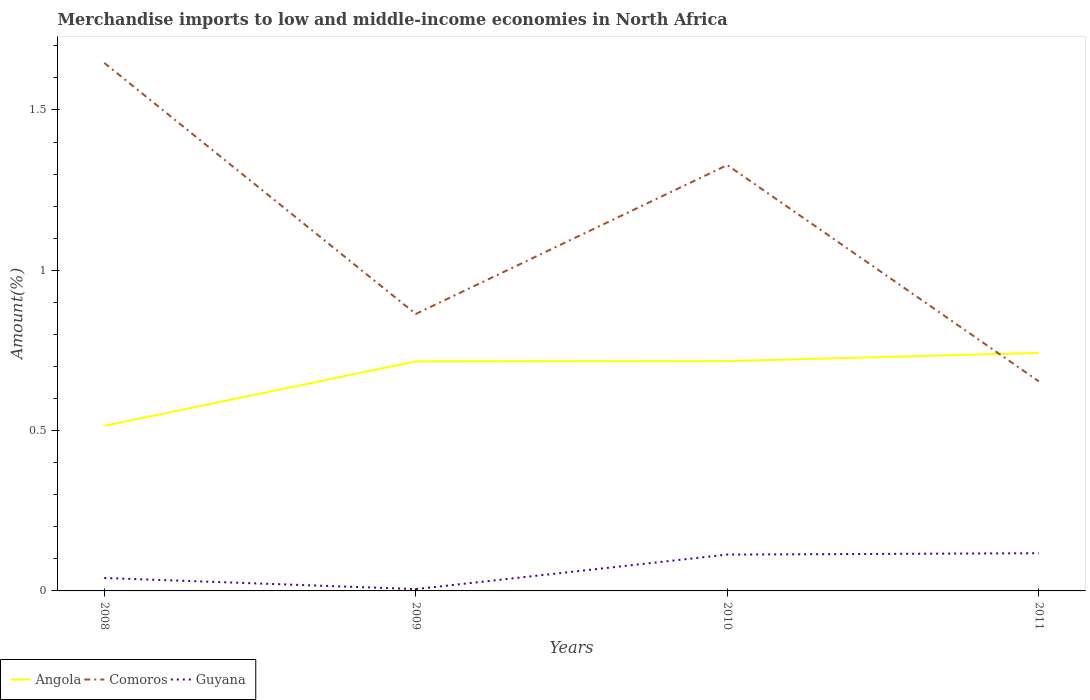Does the line corresponding to Comoros intersect with the line corresponding to Angola?
Provide a succinct answer. Yes. Across all years, what is the maximum percentage of amount earned from merchandise imports in Comoros?
Your response must be concise. 0.65. In which year was the percentage of amount earned from merchandise imports in Angola maximum?
Provide a short and direct response. 2008. What is the total percentage of amount earned from merchandise imports in Comoros in the graph?
Give a very brief answer. 0.99. What is the difference between the highest and the second highest percentage of amount earned from merchandise imports in Comoros?
Your response must be concise. 0.99. What is the difference between the highest and the lowest percentage of amount earned from merchandise imports in Guyana?
Give a very brief answer. 2. What is the difference between two consecutive major ticks on the Y-axis?
Offer a very short reply. 0.5. Does the graph contain any zero values?
Offer a very short reply. No. Does the graph contain grids?
Offer a very short reply. No. Where does the legend appear in the graph?
Ensure brevity in your answer.  Bottom left. How many legend labels are there?
Your response must be concise. 3. How are the legend labels stacked?
Give a very brief answer. Horizontal. What is the title of the graph?
Make the answer very short. Merchandise imports to low and middle-income economies in North Africa. Does "Tunisia" appear as one of the legend labels in the graph?
Provide a short and direct response. No. What is the label or title of the Y-axis?
Ensure brevity in your answer.  Amount(%). What is the Amount(%) in Angola in 2008?
Provide a succinct answer. 0.51. What is the Amount(%) of Comoros in 2008?
Your answer should be very brief. 1.65. What is the Amount(%) in Guyana in 2008?
Your response must be concise. 0.04. What is the Amount(%) of Angola in 2009?
Provide a short and direct response. 0.72. What is the Amount(%) of Comoros in 2009?
Give a very brief answer. 0.86. What is the Amount(%) in Guyana in 2009?
Your answer should be compact. 0.01. What is the Amount(%) in Angola in 2010?
Your answer should be very brief. 0.72. What is the Amount(%) in Comoros in 2010?
Provide a short and direct response. 1.33. What is the Amount(%) of Guyana in 2010?
Provide a succinct answer. 0.11. What is the Amount(%) in Angola in 2011?
Provide a short and direct response. 0.74. What is the Amount(%) of Comoros in 2011?
Make the answer very short. 0.65. What is the Amount(%) in Guyana in 2011?
Provide a short and direct response. 0.12. Across all years, what is the maximum Amount(%) in Angola?
Ensure brevity in your answer.  0.74. Across all years, what is the maximum Amount(%) of Comoros?
Your response must be concise. 1.65. Across all years, what is the maximum Amount(%) in Guyana?
Provide a succinct answer. 0.12. Across all years, what is the minimum Amount(%) of Angola?
Give a very brief answer. 0.51. Across all years, what is the minimum Amount(%) of Comoros?
Give a very brief answer. 0.65. Across all years, what is the minimum Amount(%) in Guyana?
Provide a short and direct response. 0.01. What is the total Amount(%) of Angola in the graph?
Offer a terse response. 2.69. What is the total Amount(%) in Comoros in the graph?
Your answer should be very brief. 4.49. What is the total Amount(%) of Guyana in the graph?
Keep it short and to the point. 0.28. What is the difference between the Amount(%) in Angola in 2008 and that in 2009?
Your response must be concise. -0.2. What is the difference between the Amount(%) in Comoros in 2008 and that in 2009?
Provide a succinct answer. 0.78. What is the difference between the Amount(%) in Guyana in 2008 and that in 2009?
Provide a succinct answer. 0.03. What is the difference between the Amount(%) in Angola in 2008 and that in 2010?
Ensure brevity in your answer.  -0.2. What is the difference between the Amount(%) of Comoros in 2008 and that in 2010?
Offer a very short reply. 0.32. What is the difference between the Amount(%) in Guyana in 2008 and that in 2010?
Keep it short and to the point. -0.07. What is the difference between the Amount(%) in Angola in 2008 and that in 2011?
Offer a terse response. -0.23. What is the difference between the Amount(%) in Comoros in 2008 and that in 2011?
Give a very brief answer. 0.99. What is the difference between the Amount(%) in Guyana in 2008 and that in 2011?
Your answer should be compact. -0.08. What is the difference between the Amount(%) in Angola in 2009 and that in 2010?
Your answer should be very brief. -0. What is the difference between the Amount(%) in Comoros in 2009 and that in 2010?
Your response must be concise. -0.46. What is the difference between the Amount(%) of Guyana in 2009 and that in 2010?
Keep it short and to the point. -0.11. What is the difference between the Amount(%) of Angola in 2009 and that in 2011?
Your response must be concise. -0.03. What is the difference between the Amount(%) in Comoros in 2009 and that in 2011?
Offer a terse response. 0.21. What is the difference between the Amount(%) of Guyana in 2009 and that in 2011?
Ensure brevity in your answer.  -0.11. What is the difference between the Amount(%) in Angola in 2010 and that in 2011?
Provide a short and direct response. -0.03. What is the difference between the Amount(%) of Comoros in 2010 and that in 2011?
Ensure brevity in your answer.  0.67. What is the difference between the Amount(%) in Guyana in 2010 and that in 2011?
Ensure brevity in your answer.  -0. What is the difference between the Amount(%) of Angola in 2008 and the Amount(%) of Comoros in 2009?
Your answer should be very brief. -0.35. What is the difference between the Amount(%) of Angola in 2008 and the Amount(%) of Guyana in 2009?
Your response must be concise. 0.51. What is the difference between the Amount(%) in Comoros in 2008 and the Amount(%) in Guyana in 2009?
Keep it short and to the point. 1.64. What is the difference between the Amount(%) in Angola in 2008 and the Amount(%) in Comoros in 2010?
Give a very brief answer. -0.81. What is the difference between the Amount(%) in Angola in 2008 and the Amount(%) in Guyana in 2010?
Provide a short and direct response. 0.4. What is the difference between the Amount(%) of Comoros in 2008 and the Amount(%) of Guyana in 2010?
Ensure brevity in your answer.  1.53. What is the difference between the Amount(%) in Angola in 2008 and the Amount(%) in Comoros in 2011?
Provide a short and direct response. -0.14. What is the difference between the Amount(%) in Angola in 2008 and the Amount(%) in Guyana in 2011?
Make the answer very short. 0.4. What is the difference between the Amount(%) of Comoros in 2008 and the Amount(%) of Guyana in 2011?
Give a very brief answer. 1.53. What is the difference between the Amount(%) of Angola in 2009 and the Amount(%) of Comoros in 2010?
Ensure brevity in your answer.  -0.61. What is the difference between the Amount(%) in Angola in 2009 and the Amount(%) in Guyana in 2010?
Offer a very short reply. 0.6. What is the difference between the Amount(%) in Comoros in 2009 and the Amount(%) in Guyana in 2010?
Ensure brevity in your answer.  0.75. What is the difference between the Amount(%) in Angola in 2009 and the Amount(%) in Comoros in 2011?
Provide a short and direct response. 0.06. What is the difference between the Amount(%) of Angola in 2009 and the Amount(%) of Guyana in 2011?
Ensure brevity in your answer.  0.6. What is the difference between the Amount(%) in Comoros in 2009 and the Amount(%) in Guyana in 2011?
Your answer should be compact. 0.75. What is the difference between the Amount(%) in Angola in 2010 and the Amount(%) in Comoros in 2011?
Ensure brevity in your answer.  0.06. What is the difference between the Amount(%) in Angola in 2010 and the Amount(%) in Guyana in 2011?
Ensure brevity in your answer.  0.6. What is the difference between the Amount(%) of Comoros in 2010 and the Amount(%) of Guyana in 2011?
Make the answer very short. 1.21. What is the average Amount(%) in Angola per year?
Give a very brief answer. 0.67. What is the average Amount(%) of Comoros per year?
Provide a short and direct response. 1.12. What is the average Amount(%) of Guyana per year?
Your answer should be compact. 0.07. In the year 2008, what is the difference between the Amount(%) in Angola and Amount(%) in Comoros?
Offer a very short reply. -1.13. In the year 2008, what is the difference between the Amount(%) of Angola and Amount(%) of Guyana?
Give a very brief answer. 0.47. In the year 2008, what is the difference between the Amount(%) in Comoros and Amount(%) in Guyana?
Make the answer very short. 1.61. In the year 2009, what is the difference between the Amount(%) of Angola and Amount(%) of Comoros?
Give a very brief answer. -0.15. In the year 2009, what is the difference between the Amount(%) in Angola and Amount(%) in Guyana?
Provide a succinct answer. 0.71. In the year 2009, what is the difference between the Amount(%) in Comoros and Amount(%) in Guyana?
Provide a succinct answer. 0.86. In the year 2010, what is the difference between the Amount(%) in Angola and Amount(%) in Comoros?
Give a very brief answer. -0.61. In the year 2010, what is the difference between the Amount(%) of Angola and Amount(%) of Guyana?
Offer a very short reply. 0.6. In the year 2010, what is the difference between the Amount(%) of Comoros and Amount(%) of Guyana?
Ensure brevity in your answer.  1.21. In the year 2011, what is the difference between the Amount(%) in Angola and Amount(%) in Comoros?
Keep it short and to the point. 0.09. In the year 2011, what is the difference between the Amount(%) in Angola and Amount(%) in Guyana?
Ensure brevity in your answer.  0.62. In the year 2011, what is the difference between the Amount(%) in Comoros and Amount(%) in Guyana?
Ensure brevity in your answer.  0.54. What is the ratio of the Amount(%) in Angola in 2008 to that in 2009?
Offer a very short reply. 0.72. What is the ratio of the Amount(%) of Comoros in 2008 to that in 2009?
Your answer should be compact. 1.91. What is the ratio of the Amount(%) in Guyana in 2008 to that in 2009?
Your response must be concise. 7.1. What is the ratio of the Amount(%) of Angola in 2008 to that in 2010?
Make the answer very short. 0.72. What is the ratio of the Amount(%) of Comoros in 2008 to that in 2010?
Your answer should be compact. 1.24. What is the ratio of the Amount(%) of Guyana in 2008 to that in 2010?
Ensure brevity in your answer.  0.36. What is the ratio of the Amount(%) in Angola in 2008 to that in 2011?
Offer a very short reply. 0.69. What is the ratio of the Amount(%) of Comoros in 2008 to that in 2011?
Keep it short and to the point. 2.52. What is the ratio of the Amount(%) of Guyana in 2008 to that in 2011?
Your answer should be compact. 0.34. What is the ratio of the Amount(%) of Angola in 2009 to that in 2010?
Provide a succinct answer. 1. What is the ratio of the Amount(%) in Comoros in 2009 to that in 2010?
Make the answer very short. 0.65. What is the ratio of the Amount(%) of Guyana in 2009 to that in 2010?
Give a very brief answer. 0.05. What is the ratio of the Amount(%) in Angola in 2009 to that in 2011?
Give a very brief answer. 0.96. What is the ratio of the Amount(%) of Comoros in 2009 to that in 2011?
Offer a very short reply. 1.32. What is the ratio of the Amount(%) of Guyana in 2009 to that in 2011?
Your answer should be compact. 0.05. What is the ratio of the Amount(%) in Angola in 2010 to that in 2011?
Your response must be concise. 0.97. What is the ratio of the Amount(%) of Comoros in 2010 to that in 2011?
Give a very brief answer. 2.03. What is the ratio of the Amount(%) of Guyana in 2010 to that in 2011?
Offer a very short reply. 0.96. What is the difference between the highest and the second highest Amount(%) in Angola?
Offer a terse response. 0.03. What is the difference between the highest and the second highest Amount(%) of Comoros?
Keep it short and to the point. 0.32. What is the difference between the highest and the second highest Amount(%) in Guyana?
Offer a terse response. 0. What is the difference between the highest and the lowest Amount(%) in Angola?
Keep it short and to the point. 0.23. What is the difference between the highest and the lowest Amount(%) in Comoros?
Keep it short and to the point. 0.99. What is the difference between the highest and the lowest Amount(%) in Guyana?
Keep it short and to the point. 0.11. 